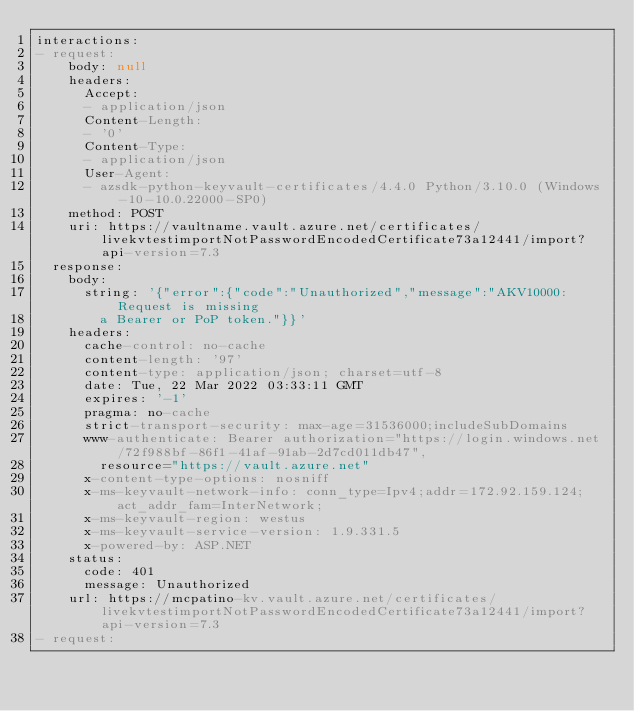Convert code to text. <code><loc_0><loc_0><loc_500><loc_500><_YAML_>interactions:
- request:
    body: null
    headers:
      Accept:
      - application/json
      Content-Length:
      - '0'
      Content-Type:
      - application/json
      User-Agent:
      - azsdk-python-keyvault-certificates/4.4.0 Python/3.10.0 (Windows-10-10.0.22000-SP0)
    method: POST
    uri: https://vaultname.vault.azure.net/certificates/livekvtestimportNotPasswordEncodedCertificate73a12441/import?api-version=7.3
  response:
    body:
      string: '{"error":{"code":"Unauthorized","message":"AKV10000: Request is missing
        a Bearer or PoP token."}}'
    headers:
      cache-control: no-cache
      content-length: '97'
      content-type: application/json; charset=utf-8
      date: Tue, 22 Mar 2022 03:33:11 GMT
      expires: '-1'
      pragma: no-cache
      strict-transport-security: max-age=31536000;includeSubDomains
      www-authenticate: Bearer authorization="https://login.windows.net/72f988bf-86f1-41af-91ab-2d7cd011db47",
        resource="https://vault.azure.net"
      x-content-type-options: nosniff
      x-ms-keyvault-network-info: conn_type=Ipv4;addr=172.92.159.124;act_addr_fam=InterNetwork;
      x-ms-keyvault-region: westus
      x-ms-keyvault-service-version: 1.9.331.5
      x-powered-by: ASP.NET
    status:
      code: 401
      message: Unauthorized
    url: https://mcpatino-kv.vault.azure.net/certificates/livekvtestimportNotPasswordEncodedCertificate73a12441/import?api-version=7.3
- request:</code> 